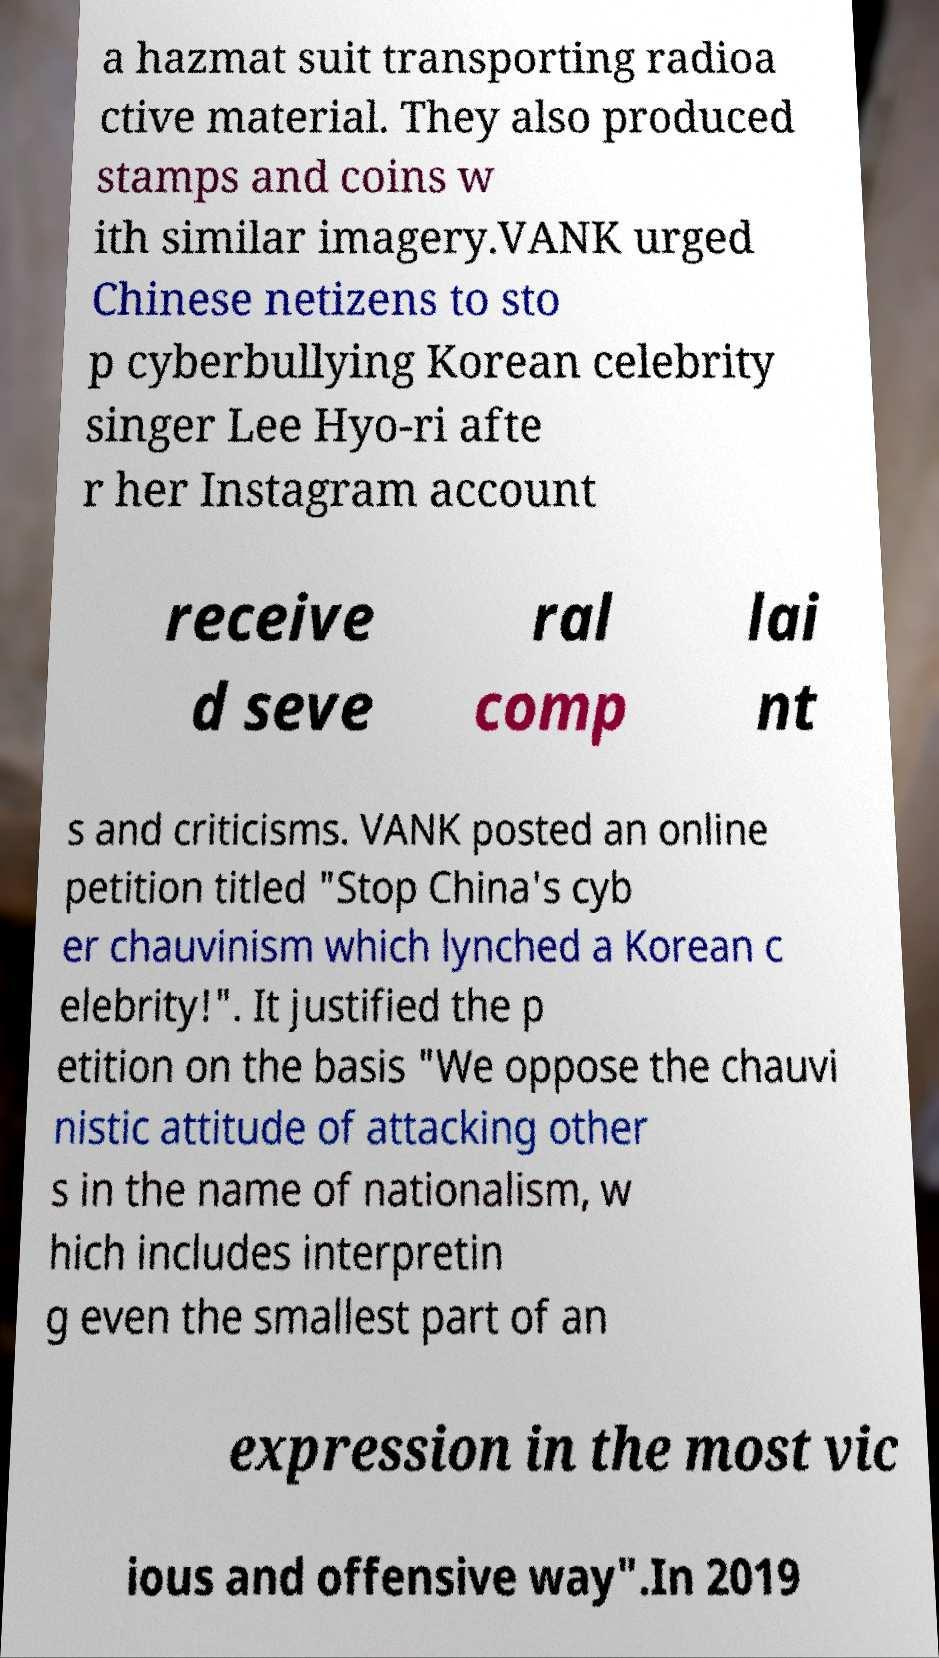Could you assist in decoding the text presented in this image and type it out clearly? a hazmat suit transporting radioa ctive material. They also produced stamps and coins w ith similar imagery.VANK urged Chinese netizens to sto p cyberbullying Korean celebrity singer Lee Hyo-ri afte r her Instagram account receive d seve ral comp lai nt s and criticisms. VANK posted an online petition titled "Stop China's cyb er chauvinism which lynched a Korean c elebrity!". It justified the p etition on the basis "We oppose the chauvi nistic attitude of attacking other s in the name of nationalism, w hich includes interpretin g even the smallest part of an expression in the most vic ious and offensive way".In 2019 